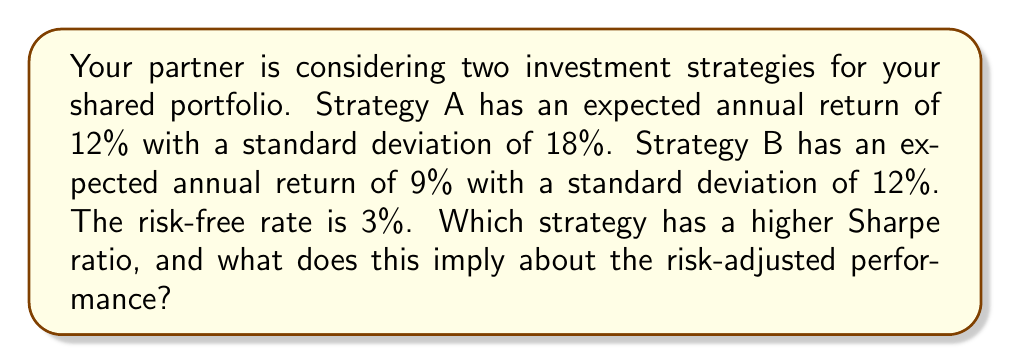Can you solve this math problem? To solve this problem, we'll calculate the Sharpe ratio for both strategies and compare them. The Sharpe ratio is a measure of risk-adjusted performance and is calculated as:

$$ \text{Sharpe Ratio} = \frac{R_p - R_f}{\sigma_p} $$

Where:
$R_p$ = Expected portfolio return
$R_f$ = Risk-free rate
$\sigma_p$ = Portfolio standard deviation

For Strategy A:
$$ \text{Sharpe Ratio}_A = \frac{0.12 - 0.03}{0.18} = \frac{0.09}{0.18} = 0.5 $$

For Strategy B:
$$ \text{Sharpe Ratio}_B = \frac{0.09 - 0.03}{0.12} = \frac{0.06}{0.12} = 0.5 $$

Both strategies have the same Sharpe ratio of 0.5. This means that both strategies offer the same risk-adjusted return. 

The interpretation of this result is that while Strategy A offers a higher expected return (12% vs 9%), it also comes with higher risk (standard deviation of 18% vs 12%). The higher return of Strategy A is exactly offset by its higher risk, resulting in the same risk-adjusted performance as Strategy B.

This analysis demonstrates the risk-return trade-off in investing. It shows that a higher return doesn't necessarily mean better performance when risk is taken into account. As a supportive partner, you might discuss with your partner how this information aligns with your shared risk tolerance and investment goals.
Answer: Both Strategy A and Strategy B have the same Sharpe ratio of 0.5, implying that they have equal risk-adjusted performance despite their different return and risk profiles. 